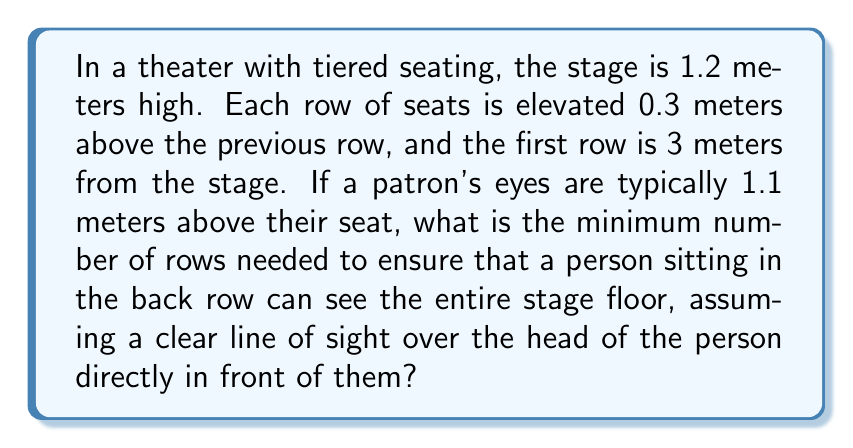Teach me how to tackle this problem. Let's approach this step-by-step:

1) First, we need to set up the geometry of the problem. Let's define:
   $h$ = height of the stage = 1.2 m
   $r$ = elevation of each row = 0.3 m
   $d$ = distance of first row from stage = 3 m
   $e$ = height of patron's eyes above seat = 1.1 m

2) We need to find the number of rows $n$ such that the line of sight from the back row just clears the head of the person in front and touches the stage floor.

3) The total height gained by the seating arrangement after $n$ rows is:
   $nr + e$

4) This height should be greater than or equal to the height required to see over the first row to the stage floor. We can express this as a proportion:

   $$\frac{nr + e}{(n+1)d} \geq \frac{h}{d}$$

5) Simplifying:
   $nr + e \geq \frac{h((n+1)d)}{d} = h(n+1)$

6) Expanding:
   $nr + e \geq hn + h$

7) Rearranging:
   $nr - hn \geq h - e$
   $n(r - h) \geq h - e$

8) Solving for $n$:
   $$n \geq \frac{h - e}{r - h} = \frac{1.2 - 1.1}{0.3 - 1.2} = \frac{0.1}{-0.9} = -\frac{1}{9}$$

9) Since we need a positive number of rows, and it must be a whole number, we round up to the nearest integer.
Answer: 1 row 